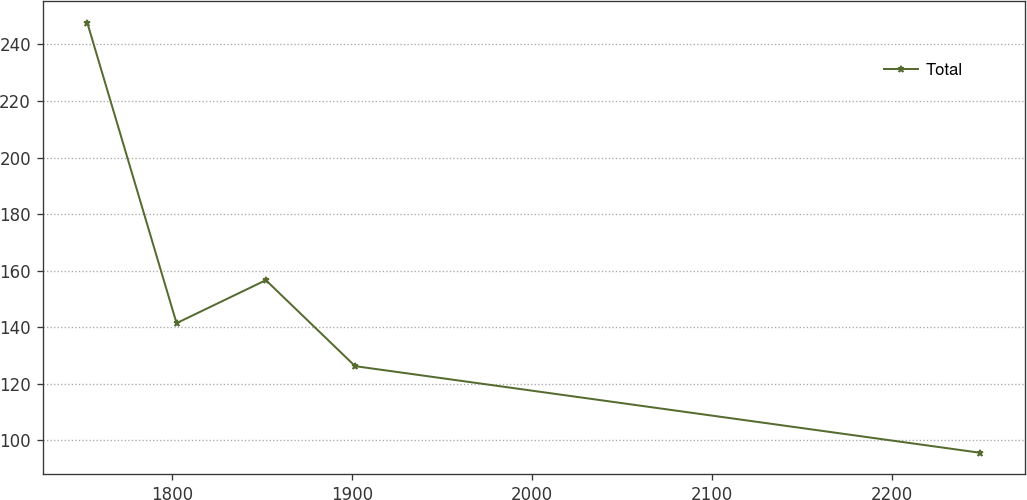<chart> <loc_0><loc_0><loc_500><loc_500><line_chart><ecel><fcel>Total<nl><fcel>1752.74<fcel>247.71<nl><fcel>1802.38<fcel>141.41<nl><fcel>1852.03<fcel>156.62<nl><fcel>1901.67<fcel>126.2<nl><fcel>2249.19<fcel>95.56<nl></chart> 